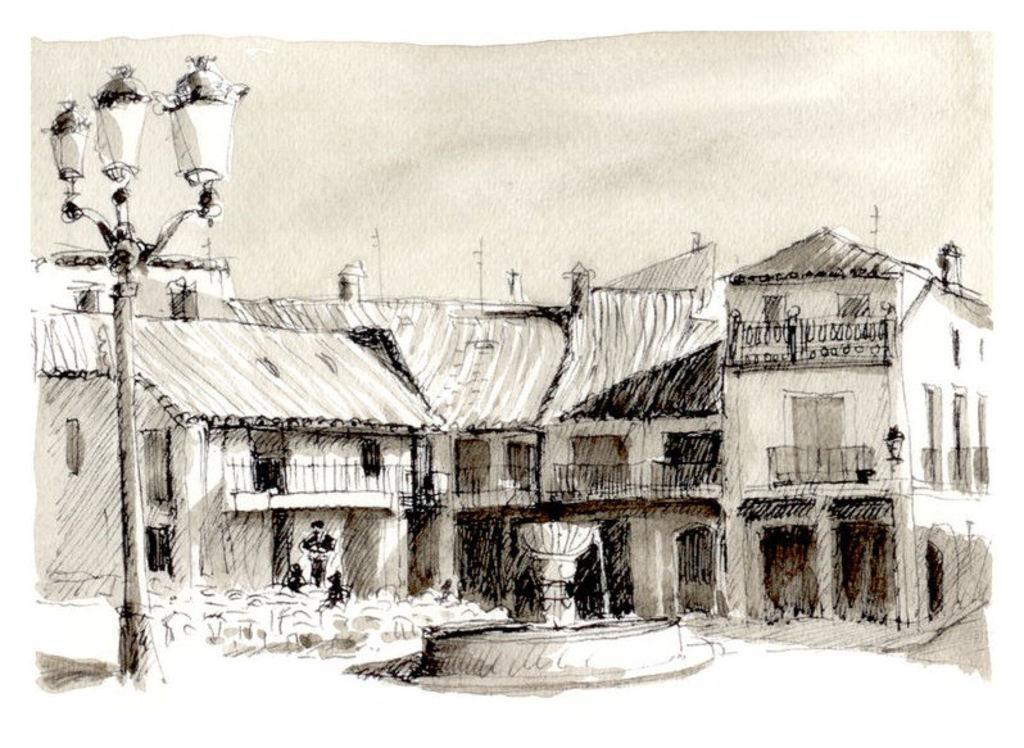How would you summarize this image in a sentence or two? In the image there is an art of buildings with water fountain in the middle and a street light on the left side and above its sky. 